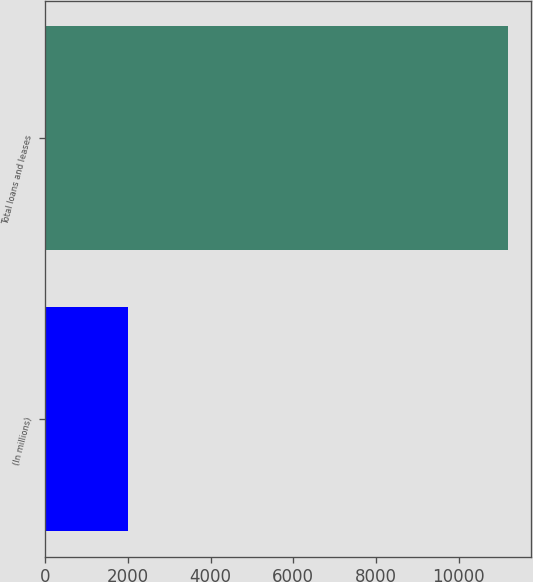Convert chart to OTSL. <chart><loc_0><loc_0><loc_500><loc_500><bar_chart><fcel>(In millions)<fcel>Total loans and leases<nl><fcel>2010<fcel>11193<nl></chart> 